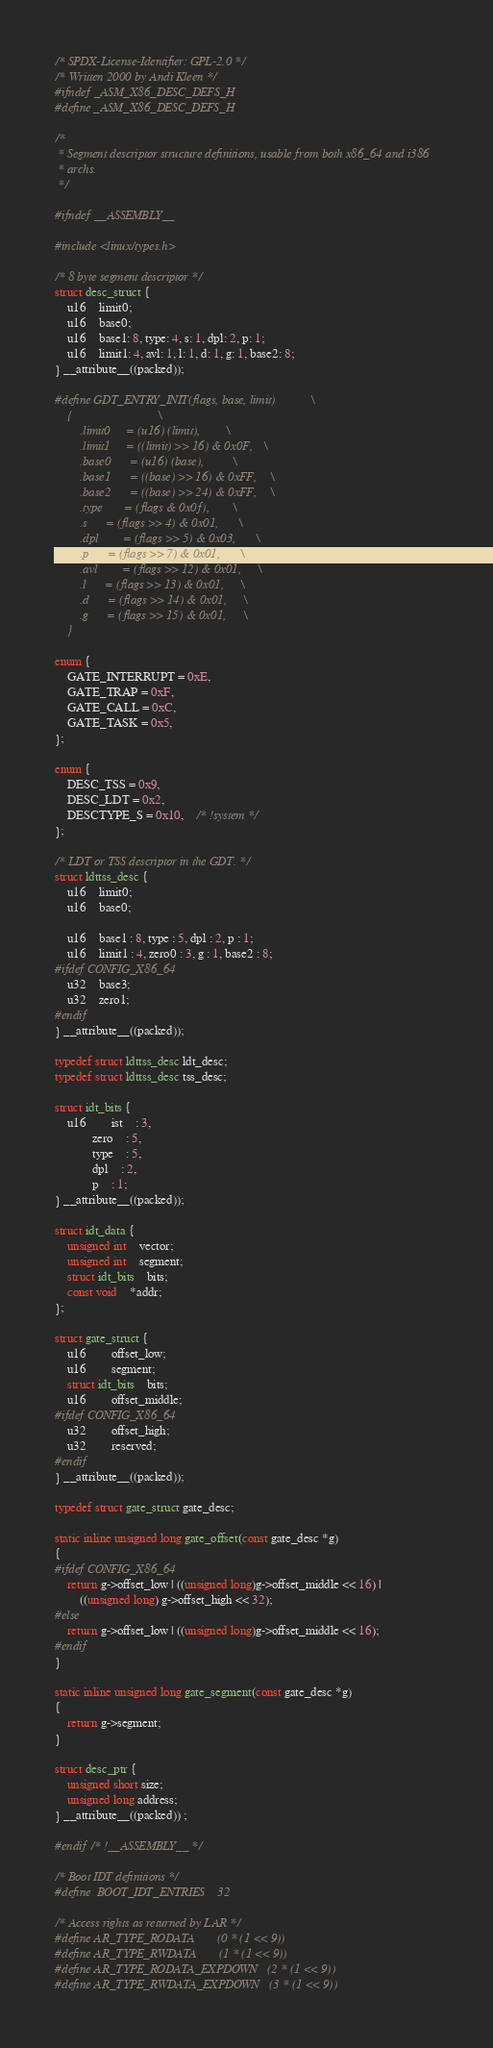Convert code to text. <code><loc_0><loc_0><loc_500><loc_500><_C_>/* SPDX-License-Identifier: GPL-2.0 */
/* Written 2000 by Andi Kleen */
#ifndef _ASM_X86_DESC_DEFS_H
#define _ASM_X86_DESC_DEFS_H

/*
 * Segment descriptor structure definitions, usable from both x86_64 and i386
 * archs.
 */

#ifndef __ASSEMBLY__

#include <linux/types.h>

/* 8 byte segment descriptor */
struct desc_struct {
	u16	limit0;
	u16	base0;
	u16	base1: 8, type: 4, s: 1, dpl: 2, p: 1;
	u16	limit1: 4, avl: 1, l: 1, d: 1, g: 1, base2: 8;
} __attribute__((packed));

#define GDT_ENTRY_INIT(flags, base, limit)			\
	{							\
		.limit0		= (u16) (limit),		\
		.limit1		= ((limit) >> 16) & 0x0F,	\
		.base0		= (u16) (base),			\
		.base1		= ((base) >> 16) & 0xFF,	\
		.base2		= ((base) >> 24) & 0xFF,	\
		.type		= (flags & 0x0f),		\
		.s		= (flags >> 4) & 0x01,		\
		.dpl		= (flags >> 5) & 0x03,		\
		.p		= (flags >> 7) & 0x01,		\
		.avl		= (flags >> 12) & 0x01,		\
		.l		= (flags >> 13) & 0x01,		\
		.d		= (flags >> 14) & 0x01,		\
		.g		= (flags >> 15) & 0x01,		\
	}

enum {
	GATE_INTERRUPT = 0xE,
	GATE_TRAP = 0xF,
	GATE_CALL = 0xC,
	GATE_TASK = 0x5,
};

enum {
	DESC_TSS = 0x9,
	DESC_LDT = 0x2,
	DESCTYPE_S = 0x10,	/* !system */
};

/* LDT or TSS descriptor in the GDT. */
struct ldttss_desc {
	u16	limit0;
	u16	base0;

	u16	base1 : 8, type : 5, dpl : 2, p : 1;
	u16	limit1 : 4, zero0 : 3, g : 1, base2 : 8;
#ifdef CONFIG_X86_64
	u32	base3;
	u32	zero1;
#endif
} __attribute__((packed));

typedef struct ldttss_desc ldt_desc;
typedef struct ldttss_desc tss_desc;

struct idt_bits {
	u16		ist	: 3,
			zero	: 5,
			type	: 5,
			dpl	: 2,
			p	: 1;
} __attribute__((packed));

struct idt_data {
	unsigned int	vector;
	unsigned int	segment;
	struct idt_bits	bits;
	const void	*addr;
};

struct gate_struct {
	u16		offset_low;
	u16		segment;
	struct idt_bits	bits;
	u16		offset_middle;
#ifdef CONFIG_X86_64
	u32		offset_high;
	u32		reserved;
#endif
} __attribute__((packed));

typedef struct gate_struct gate_desc;

static inline unsigned long gate_offset(const gate_desc *g)
{
#ifdef CONFIG_X86_64
	return g->offset_low | ((unsigned long)g->offset_middle << 16) |
		((unsigned long) g->offset_high << 32);
#else
	return g->offset_low | ((unsigned long)g->offset_middle << 16);
#endif
}

static inline unsigned long gate_segment(const gate_desc *g)
{
	return g->segment;
}

struct desc_ptr {
	unsigned short size;
	unsigned long address;
} __attribute__((packed)) ;

#endif /* !__ASSEMBLY__ */

/* Boot IDT definitions */
#define	BOOT_IDT_ENTRIES	32

/* Access rights as returned by LAR */
#define AR_TYPE_RODATA		(0 * (1 << 9))
#define AR_TYPE_RWDATA		(1 * (1 << 9))
#define AR_TYPE_RODATA_EXPDOWN	(2 * (1 << 9))
#define AR_TYPE_RWDATA_EXPDOWN	(3 * (1 << 9))</code> 